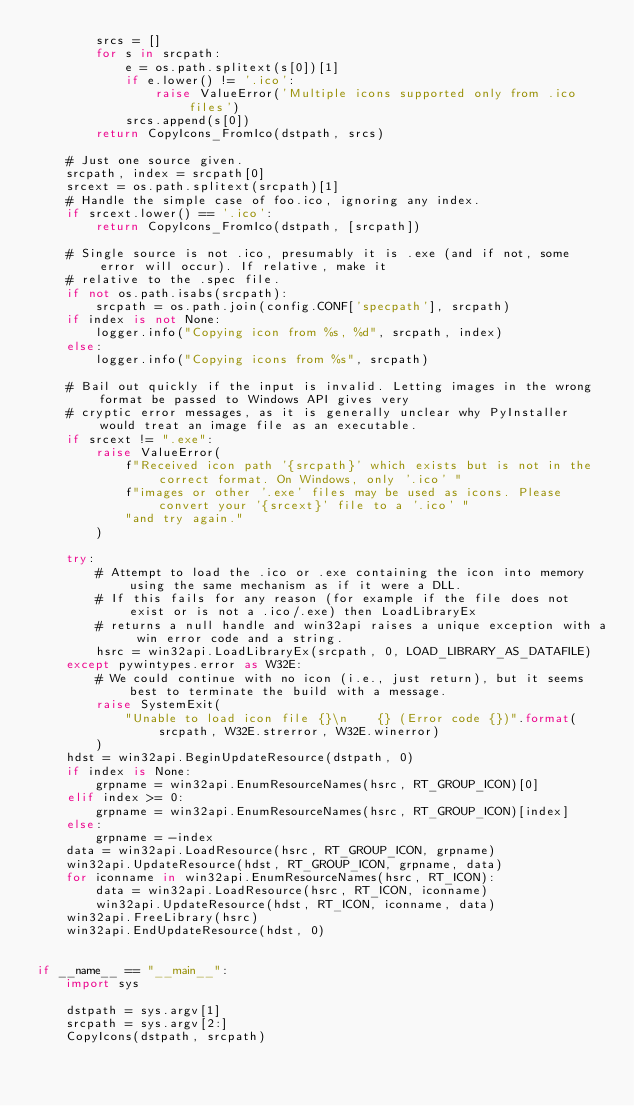<code> <loc_0><loc_0><loc_500><loc_500><_Python_>        srcs = []
        for s in srcpath:
            e = os.path.splitext(s[0])[1]
            if e.lower() != '.ico':
                raise ValueError('Multiple icons supported only from .ico files')
            srcs.append(s[0])
        return CopyIcons_FromIco(dstpath, srcs)

    # Just one source given.
    srcpath, index = srcpath[0]
    srcext = os.path.splitext(srcpath)[1]
    # Handle the simple case of foo.ico, ignoring any index.
    if srcext.lower() == '.ico':
        return CopyIcons_FromIco(dstpath, [srcpath])

    # Single source is not .ico, presumably it is .exe (and if not, some error will occur). If relative, make it
    # relative to the .spec file.
    if not os.path.isabs(srcpath):
        srcpath = os.path.join(config.CONF['specpath'], srcpath)
    if index is not None:
        logger.info("Copying icon from %s, %d", srcpath, index)
    else:
        logger.info("Copying icons from %s", srcpath)

    # Bail out quickly if the input is invalid. Letting images in the wrong format be passed to Windows API gives very
    # cryptic error messages, as it is generally unclear why PyInstaller would treat an image file as an executable.
    if srcext != ".exe":
        raise ValueError(
            f"Received icon path '{srcpath}' which exists but is not in the correct format. On Windows, only '.ico' "
            f"images or other '.exe' files may be used as icons. Please convert your '{srcext}' file to a '.ico' "
            "and try again."
        )

    try:
        # Attempt to load the .ico or .exe containing the icon into memory using the same mechanism as if it were a DLL.
        # If this fails for any reason (for example if the file does not exist or is not a .ico/.exe) then LoadLibraryEx
        # returns a null handle and win32api raises a unique exception with a win error code and a string.
        hsrc = win32api.LoadLibraryEx(srcpath, 0, LOAD_LIBRARY_AS_DATAFILE)
    except pywintypes.error as W32E:
        # We could continue with no icon (i.e., just return), but it seems best to terminate the build with a message.
        raise SystemExit(
            "Unable to load icon file {}\n    {} (Error code {})".format(srcpath, W32E.strerror, W32E.winerror)
        )
    hdst = win32api.BeginUpdateResource(dstpath, 0)
    if index is None:
        grpname = win32api.EnumResourceNames(hsrc, RT_GROUP_ICON)[0]
    elif index >= 0:
        grpname = win32api.EnumResourceNames(hsrc, RT_GROUP_ICON)[index]
    else:
        grpname = -index
    data = win32api.LoadResource(hsrc, RT_GROUP_ICON, grpname)
    win32api.UpdateResource(hdst, RT_GROUP_ICON, grpname, data)
    for iconname in win32api.EnumResourceNames(hsrc, RT_ICON):
        data = win32api.LoadResource(hsrc, RT_ICON, iconname)
        win32api.UpdateResource(hdst, RT_ICON, iconname, data)
    win32api.FreeLibrary(hsrc)
    win32api.EndUpdateResource(hdst, 0)


if __name__ == "__main__":
    import sys

    dstpath = sys.argv[1]
    srcpath = sys.argv[2:]
    CopyIcons(dstpath, srcpath)
</code> 